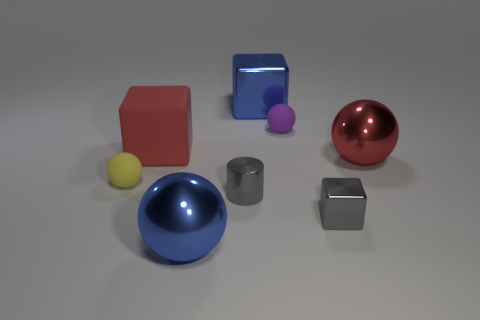Is the number of small matte spheres that are in front of the big red matte block greater than the number of red rubber objects that are in front of the tiny shiny cylinder?
Your response must be concise. Yes. What size is the red metal thing?
Offer a terse response. Large. What shape is the big blue object that is behind the red shiny sphere?
Offer a terse response. Cube. Does the yellow object have the same shape as the large red metallic thing?
Provide a short and direct response. Yes. Are there an equal number of tiny gray cylinders behind the tiny gray metallic block and small brown cylinders?
Ensure brevity in your answer.  No. What is the shape of the red metal thing?
Offer a very short reply. Sphere. Is there anything else that has the same color as the tiny shiny cube?
Offer a very short reply. Yes. Do the metallic sphere on the right side of the big blue metallic ball and the metal cube behind the gray metal cube have the same size?
Your answer should be very brief. Yes. The small thing to the left of the big blue thing that is in front of the yellow sphere is what shape?
Keep it short and to the point. Sphere. Is the size of the gray metallic block the same as the thing behind the purple matte object?
Your response must be concise. No. 